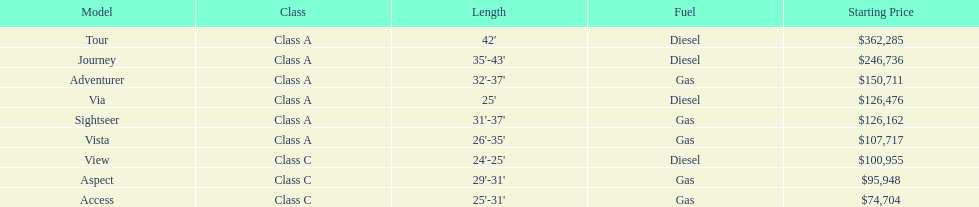Which model is a diesel, the tour or the aspect? Tour. 